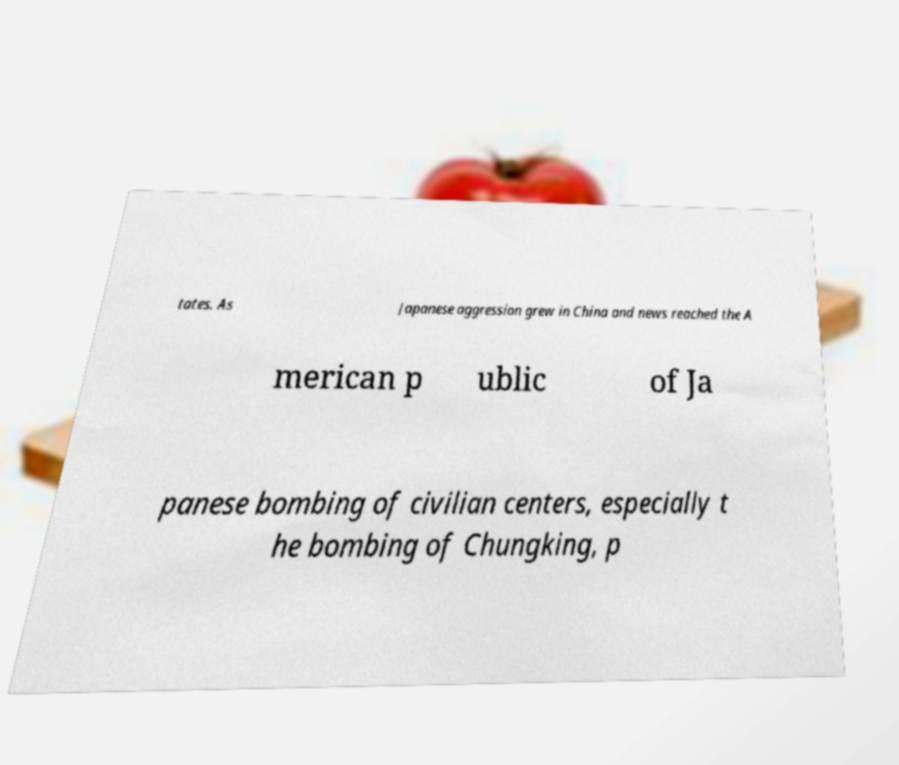Please identify and transcribe the text found in this image. tates. As Japanese aggression grew in China and news reached the A merican p ublic of Ja panese bombing of civilian centers, especially t he bombing of Chungking, p 